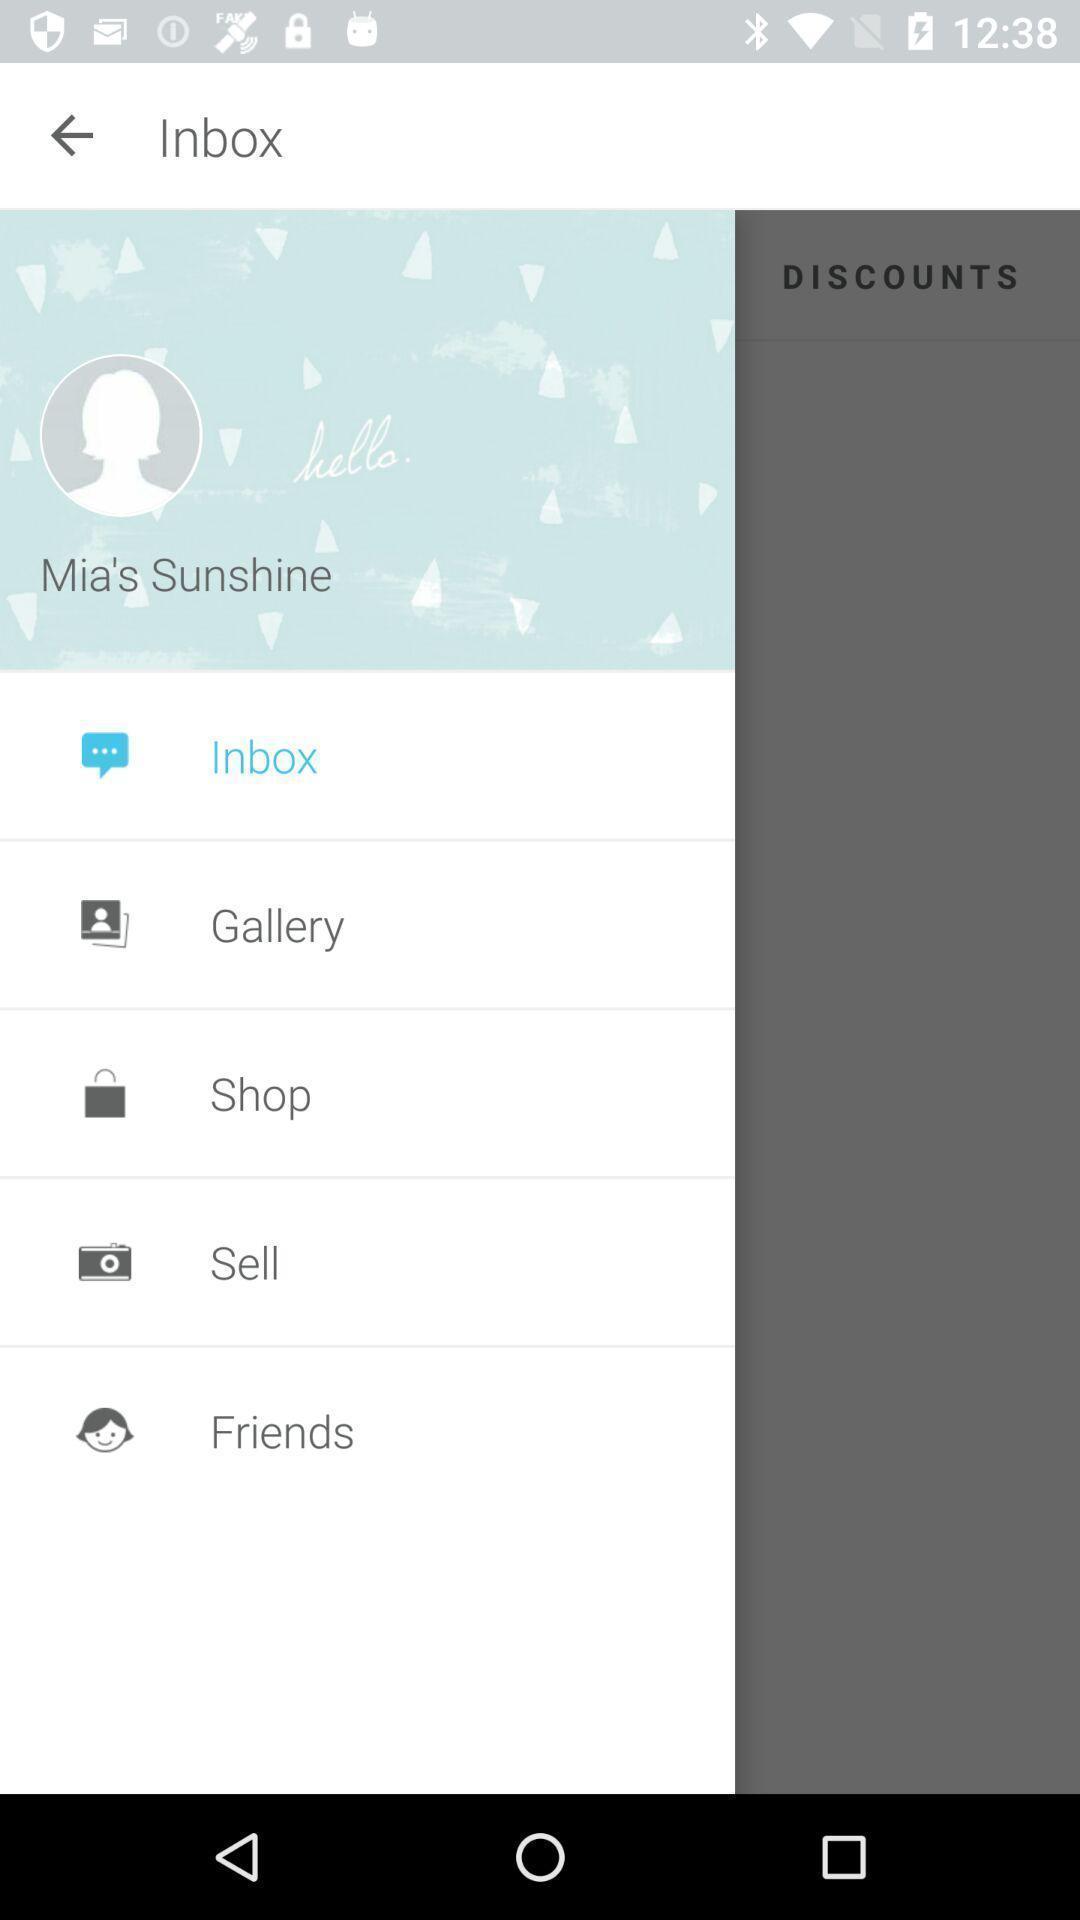Explain what's happening in this screen capture. Screen shows inbox of a social application. 